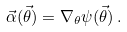Convert formula to latex. <formula><loc_0><loc_0><loc_500><loc_500>\vec { \alpha } ( \vec { \theta } ) = \nabla _ { \theta } \psi ( \vec { \theta } ) \, .</formula> 